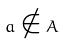<formula> <loc_0><loc_0><loc_500><loc_500>a \notin A</formula> 